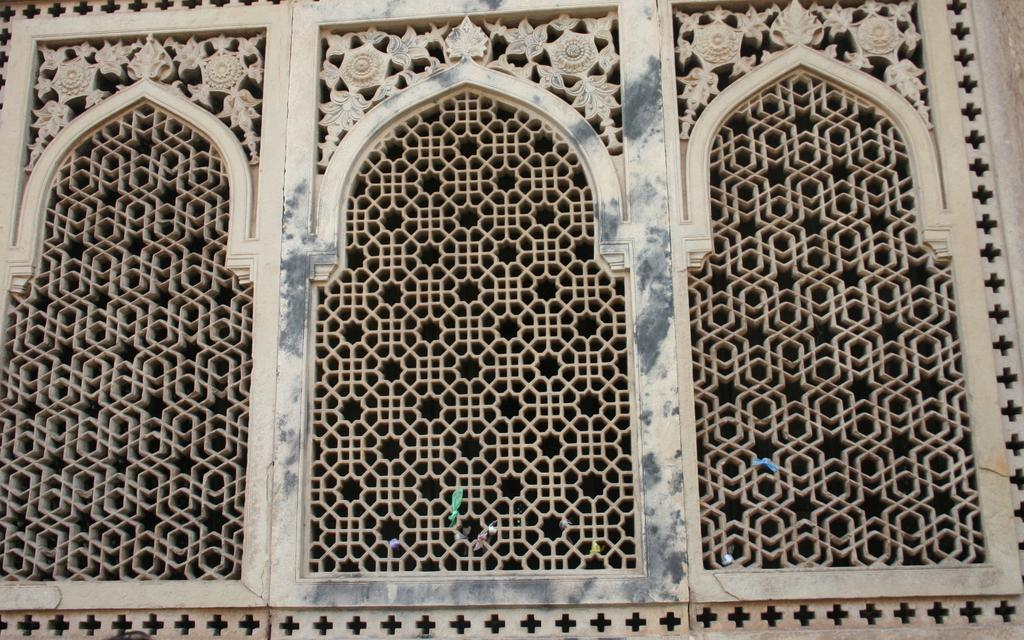How many arches are present in the image? There are three arches in the image. What can be observed about the design of each arch? Each arch has a different design. What type of currency is being exchanged on the top of the arches in the image? There is no exchange of currency or any indication of a top in the image; it only features three arches with different designs. 